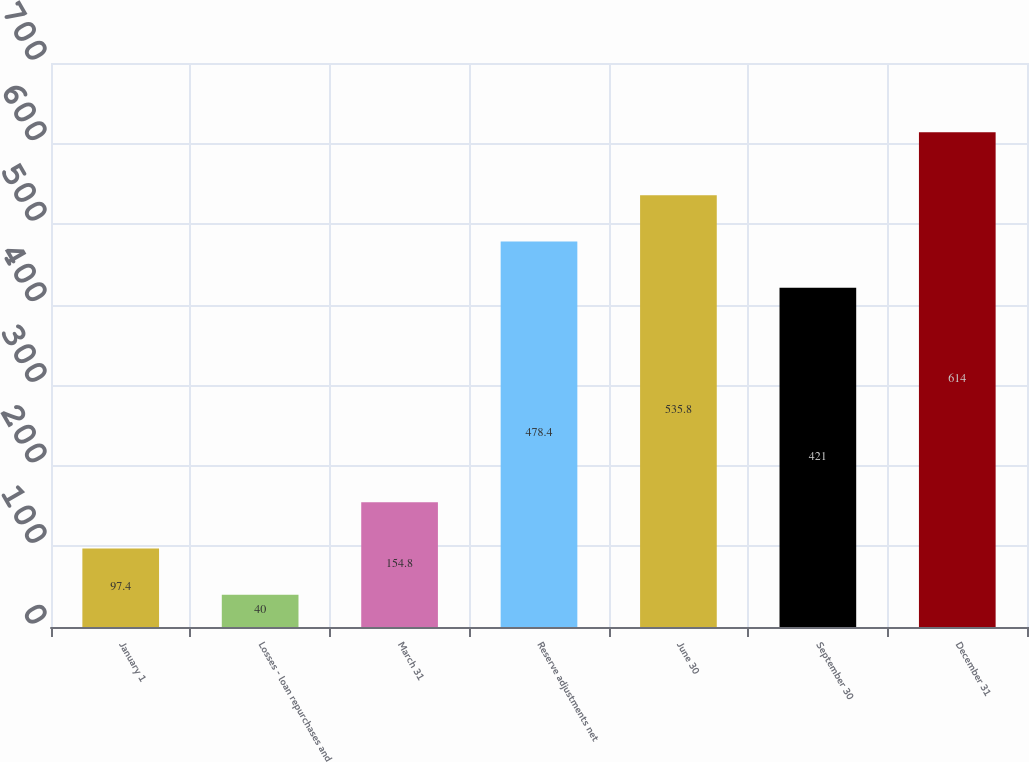<chart> <loc_0><loc_0><loc_500><loc_500><bar_chart><fcel>January 1<fcel>Losses - loan repurchases and<fcel>March 31<fcel>Reserve adjustments net<fcel>June 30<fcel>September 30<fcel>December 31<nl><fcel>97.4<fcel>40<fcel>154.8<fcel>478.4<fcel>535.8<fcel>421<fcel>614<nl></chart> 